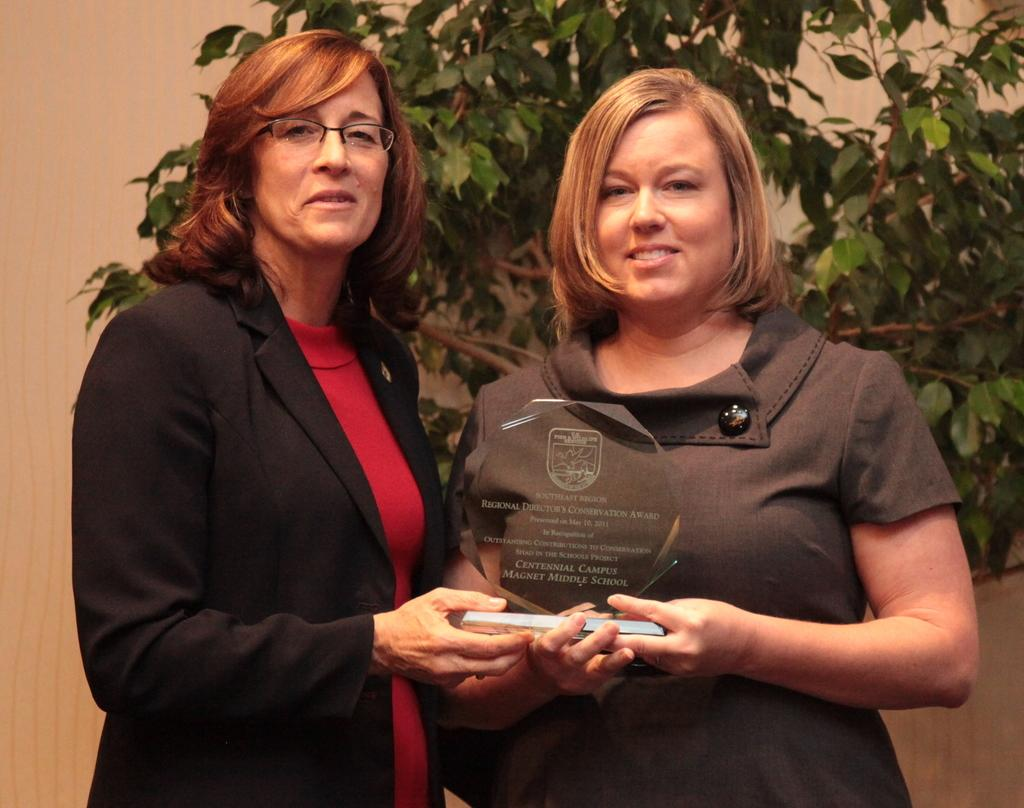What type of structure is visible in the image? There is a wall in the image. What natural element can be seen in the image? There is a tree in the image. How many people are present in the image? There are two people standing in the front of the image. How many rabbits are hiding behind the bushes in the image? There are no rabbits or bushes present in the image. 